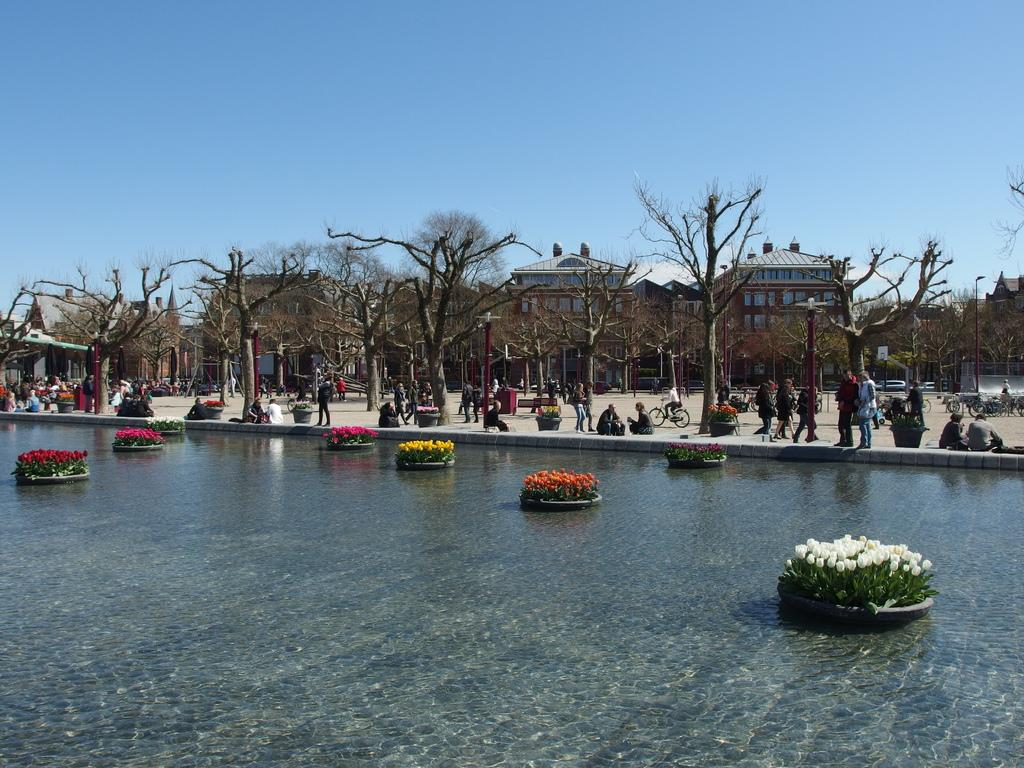What type of natural elements can be seen in the image? There are trees in the image. What type of man-made structures are present in the image? There are buildings in the image. What body of water is visible in the image? There is water visible in the image. What part of the natural environment is visible in the image? The sky is visible in the image. What type of watch can be seen on the tree in the image? There is no watch present in the image; it features trees, buildings, water, and the sky. What type of appliance is being used by the trees in the image? There are no appliances present in the image, as it features trees, buildings, water, and the sky. 